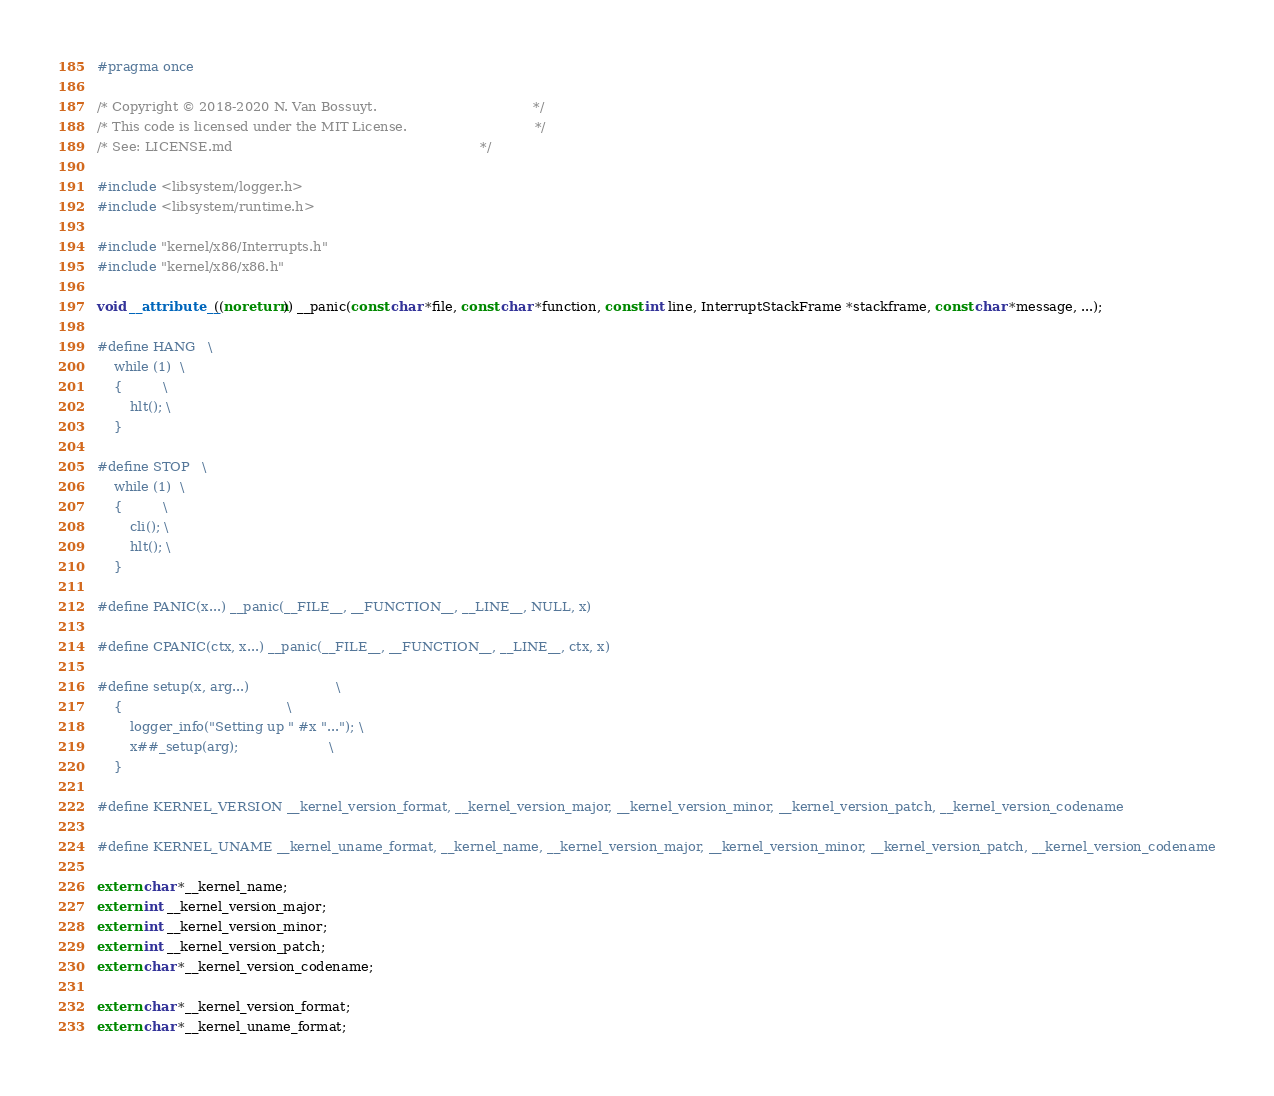<code> <loc_0><loc_0><loc_500><loc_500><_C_>#pragma once

/* Copyright © 2018-2020 N. Van Bossuyt.                                      */
/* This code is licensed under the MIT License.                               */
/* See: LICENSE.md                                                            */

#include <libsystem/logger.h>
#include <libsystem/runtime.h>

#include "kernel/x86/Interrupts.h"
#include "kernel/x86/x86.h"

void __attribute__((noreturn)) __panic(const char *file, const char *function, const int line, InterruptStackFrame *stackframe, const char *message, ...);

#define HANG   \
    while (1)  \
    {          \
        hlt(); \
    }

#define STOP   \
    while (1)  \
    {          \
        cli(); \
        hlt(); \
    }

#define PANIC(x...) __panic(__FILE__, __FUNCTION__, __LINE__, NULL, x)

#define CPANIC(ctx, x...) __panic(__FILE__, __FUNCTION__, __LINE__, ctx, x)

#define setup(x, arg...)                     \
    {                                        \
        logger_info("Setting up " #x "..."); \
        x##_setup(arg);                      \
    }

#define KERNEL_VERSION __kernel_version_format, __kernel_version_major, __kernel_version_minor, __kernel_version_patch, __kernel_version_codename

#define KERNEL_UNAME __kernel_uname_format, __kernel_name, __kernel_version_major, __kernel_version_minor, __kernel_version_patch, __kernel_version_codename

extern char *__kernel_name;
extern int __kernel_version_major;
extern int __kernel_version_minor;
extern int __kernel_version_patch;
extern char *__kernel_version_codename;

extern char *__kernel_version_format;
extern char *__kernel_uname_format;
</code> 